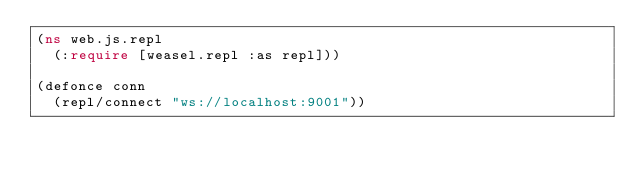Convert code to text. <code><loc_0><loc_0><loc_500><loc_500><_Clojure_>(ns web.js.repl
  (:require [weasel.repl :as repl]))

(defonce conn
  (repl/connect "ws://localhost:9001"))
</code> 